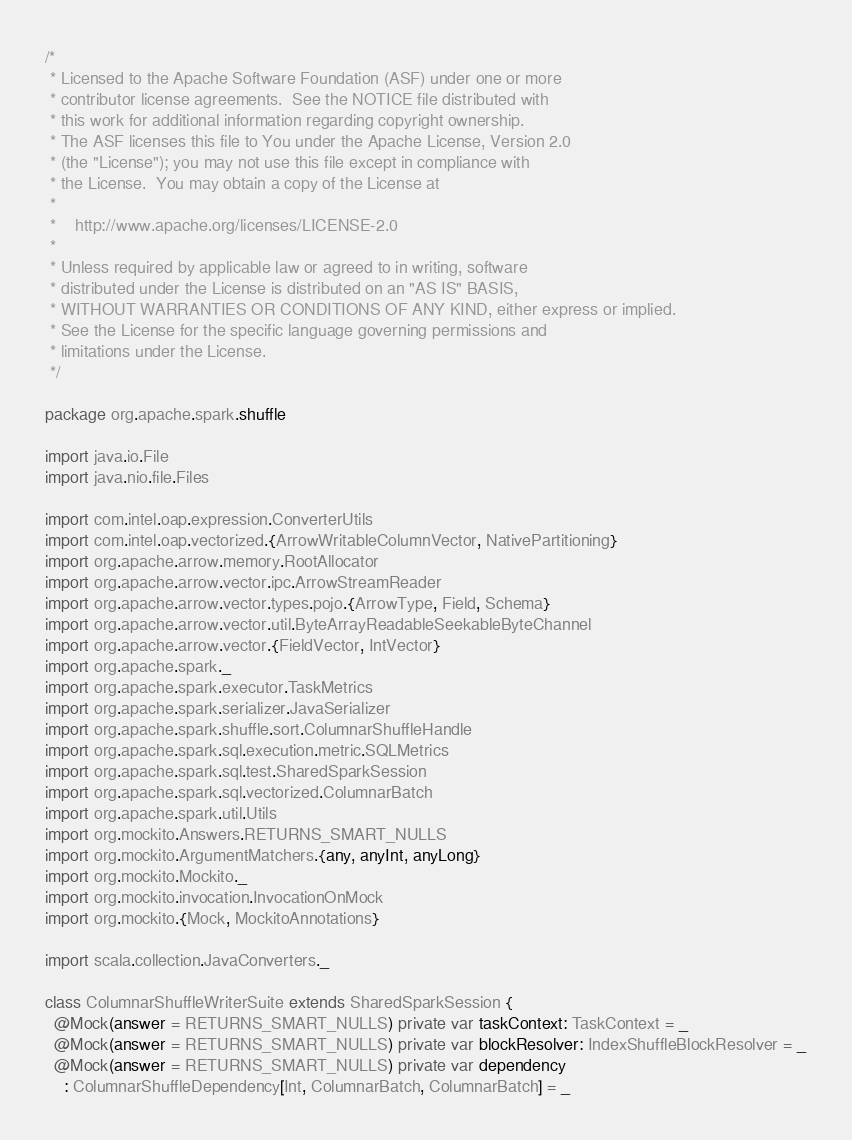<code> <loc_0><loc_0><loc_500><loc_500><_Scala_>/*
 * Licensed to the Apache Software Foundation (ASF) under one or more
 * contributor license agreements.  See the NOTICE file distributed with
 * this work for additional information regarding copyright ownership.
 * The ASF licenses this file to You under the Apache License, Version 2.0
 * (the "License"); you may not use this file except in compliance with
 * the License.  You may obtain a copy of the License at
 *
 *    http://www.apache.org/licenses/LICENSE-2.0
 *
 * Unless required by applicable law or agreed to in writing, software
 * distributed under the License is distributed on an "AS IS" BASIS,
 * WITHOUT WARRANTIES OR CONDITIONS OF ANY KIND, either express or implied.
 * See the License for the specific language governing permissions and
 * limitations under the License.
 */

package org.apache.spark.shuffle

import java.io.File
import java.nio.file.Files

import com.intel.oap.expression.ConverterUtils
import com.intel.oap.vectorized.{ArrowWritableColumnVector, NativePartitioning}
import org.apache.arrow.memory.RootAllocator
import org.apache.arrow.vector.ipc.ArrowStreamReader
import org.apache.arrow.vector.types.pojo.{ArrowType, Field, Schema}
import org.apache.arrow.vector.util.ByteArrayReadableSeekableByteChannel
import org.apache.arrow.vector.{FieldVector, IntVector}
import org.apache.spark._
import org.apache.spark.executor.TaskMetrics
import org.apache.spark.serializer.JavaSerializer
import org.apache.spark.shuffle.sort.ColumnarShuffleHandle
import org.apache.spark.sql.execution.metric.SQLMetrics
import org.apache.spark.sql.test.SharedSparkSession
import org.apache.spark.sql.vectorized.ColumnarBatch
import org.apache.spark.util.Utils
import org.mockito.Answers.RETURNS_SMART_NULLS
import org.mockito.ArgumentMatchers.{any, anyInt, anyLong}
import org.mockito.Mockito._
import org.mockito.invocation.InvocationOnMock
import org.mockito.{Mock, MockitoAnnotations}

import scala.collection.JavaConverters._

class ColumnarShuffleWriterSuite extends SharedSparkSession {
  @Mock(answer = RETURNS_SMART_NULLS) private var taskContext: TaskContext = _
  @Mock(answer = RETURNS_SMART_NULLS) private var blockResolver: IndexShuffleBlockResolver = _
  @Mock(answer = RETURNS_SMART_NULLS) private var dependency
    : ColumnarShuffleDependency[Int, ColumnarBatch, ColumnarBatch] = _
</code> 